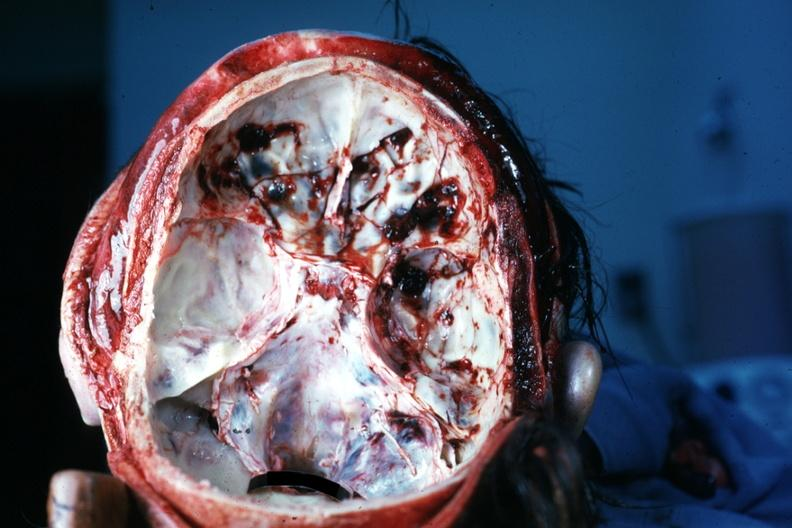what is present?
Answer the question using a single word or phrase. Bone 